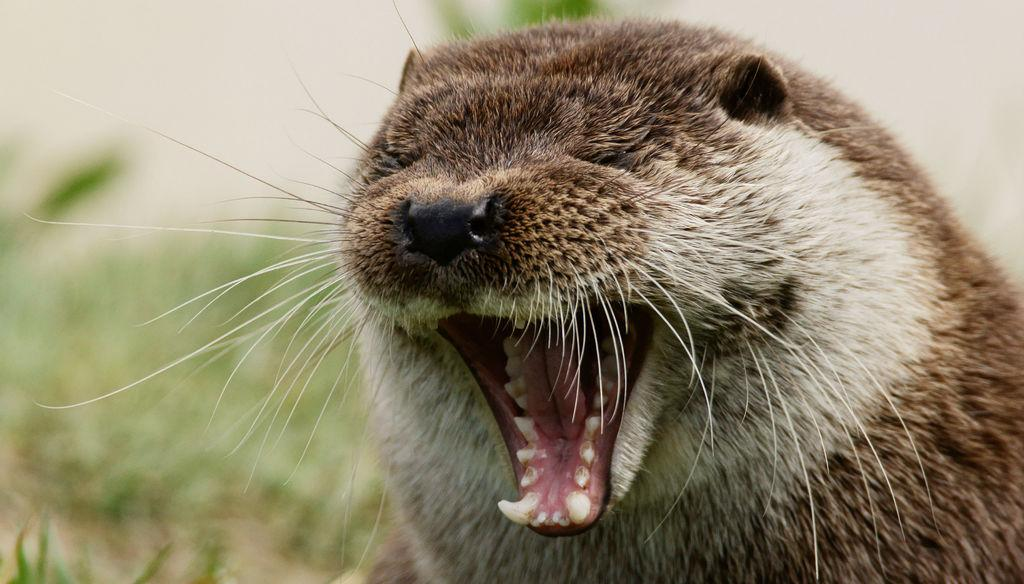What type of animal is in the picture? The type of animal cannot be determined from the provided facts. What is the animal doing in the picture? The animal has its mouth open in the picture. How would you describe the background of the image? The background of the image is blurred. What type of mist can be seen in the alley where the animal is taking a bath? There is no mention of mist, alley, or bath in the provided facts. The image only shows an animal with its mouth open, and the background is blurred. 